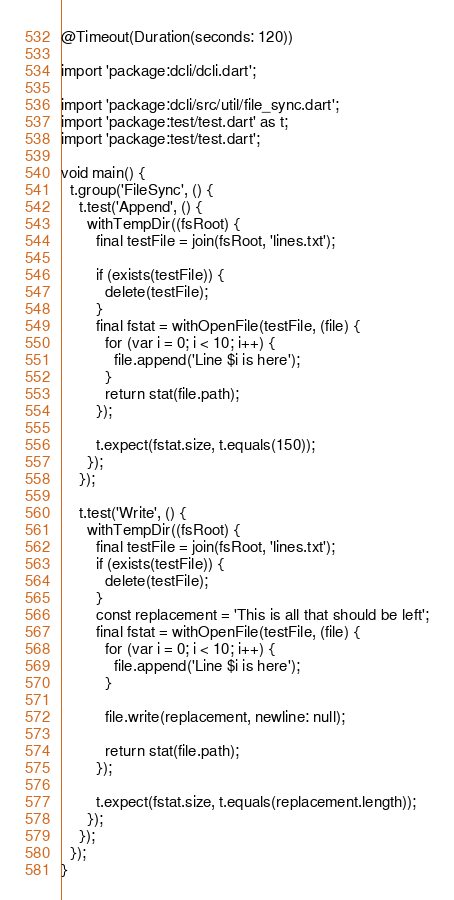Convert code to text. <code><loc_0><loc_0><loc_500><loc_500><_Dart_>@Timeout(Duration(seconds: 120))

import 'package:dcli/dcli.dart';

import 'package:dcli/src/util/file_sync.dart';
import 'package:test/test.dart' as t;
import 'package:test/test.dart';

void main() {
  t.group('FileSync', () {
    t.test('Append', () {
      withTempDir((fsRoot) {
        final testFile = join(fsRoot, 'lines.txt');

        if (exists(testFile)) {
          delete(testFile);
        }
        final fstat = withOpenFile(testFile, (file) {
          for (var i = 0; i < 10; i++) {
            file.append('Line $i is here');
          }
          return stat(file.path);
        });

        t.expect(fstat.size, t.equals(150));
      });
    });

    t.test('Write', () {
      withTempDir((fsRoot) {
        final testFile = join(fsRoot, 'lines.txt');
        if (exists(testFile)) {
          delete(testFile);
        }
        const replacement = 'This is all that should be left';
        final fstat = withOpenFile(testFile, (file) {
          for (var i = 0; i < 10; i++) {
            file.append('Line $i is here');
          }

          file.write(replacement, newline: null);

          return stat(file.path);
        });

        t.expect(fstat.size, t.equals(replacement.length));
      });
    });
  });
}
</code> 